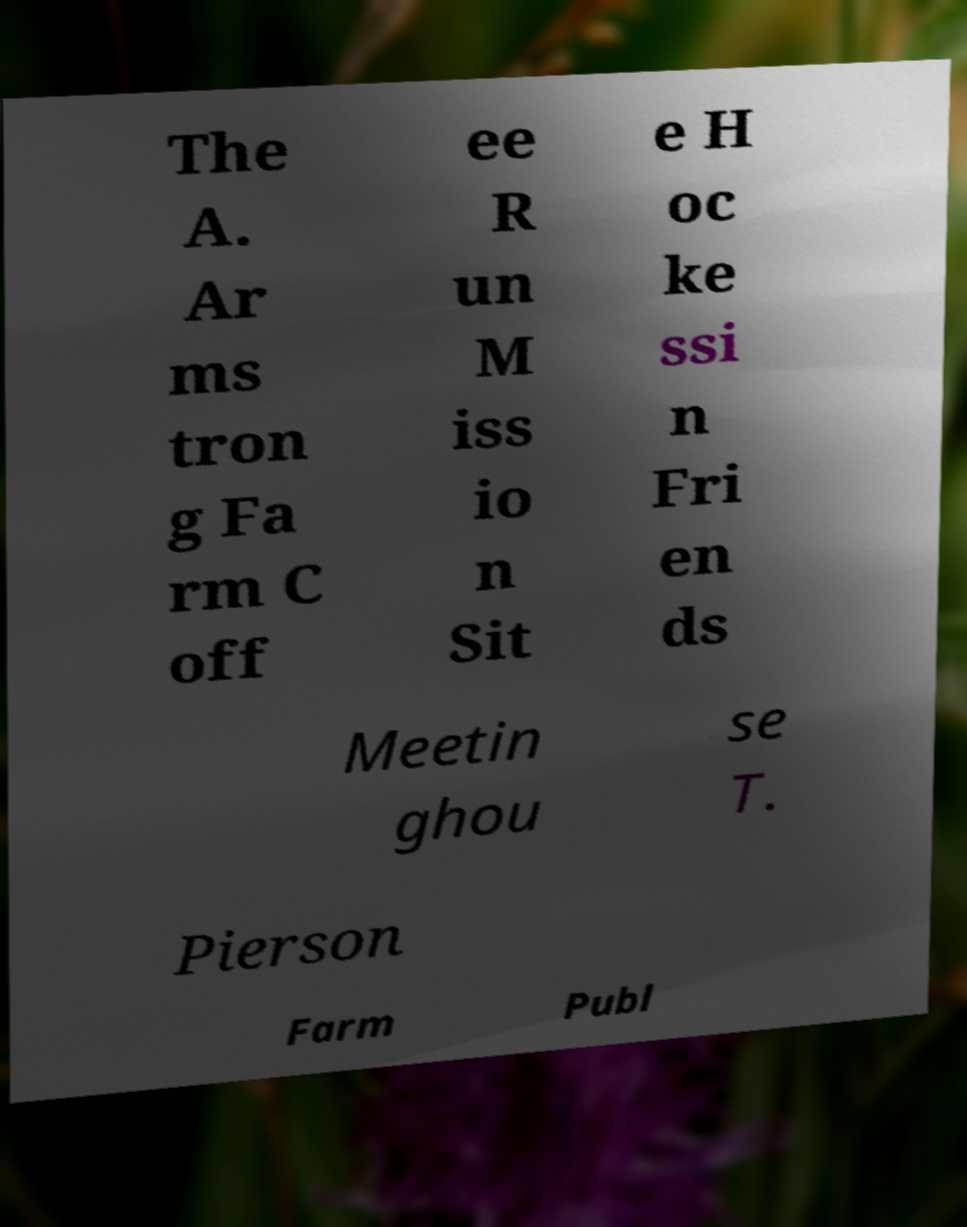I need the written content from this picture converted into text. Can you do that? The A. Ar ms tron g Fa rm C off ee R un M iss io n Sit e H oc ke ssi n Fri en ds Meetin ghou se T. Pierson Farm Publ 